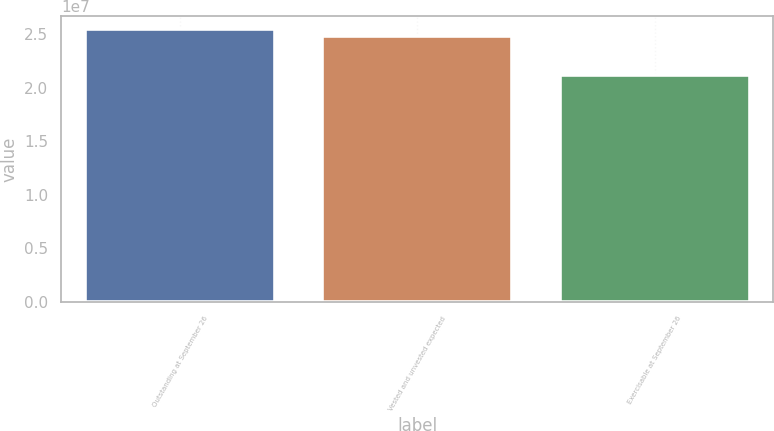Convert chart to OTSL. <chart><loc_0><loc_0><loc_500><loc_500><bar_chart><fcel>Outstanding at September 26<fcel>Vested and unvested expected<fcel>Exercisable at September 26<nl><fcel>2.5465e+07<fcel>2.48442e+07<fcel>2.11851e+07<nl></chart> 